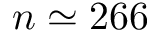<formula> <loc_0><loc_0><loc_500><loc_500>n \simeq 2 6 6</formula> 